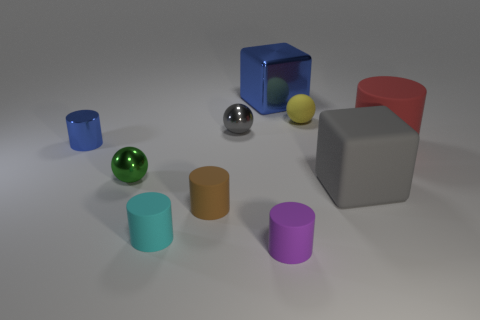What number of large gray matte blocks are in front of the blue thing left of the small purple rubber cylinder?
Offer a terse response. 1. How many matte cylinders are right of the tiny yellow sphere?
Provide a short and direct response. 1. There is a tiny shiny sphere on the left side of the shiny ball behind the blue object that is in front of the big blue object; what is its color?
Your response must be concise. Green. There is a small metal ball in front of the large matte cylinder; is it the same color as the small rubber cylinder behind the tiny cyan cylinder?
Provide a short and direct response. No. There is a small brown rubber object to the left of the big matte thing behind the large rubber cube; what is its shape?
Provide a short and direct response. Cylinder. Are there any green metallic spheres of the same size as the brown matte thing?
Your answer should be compact. Yes. What number of other gray shiny things have the same shape as the tiny gray thing?
Give a very brief answer. 0. Is the number of tiny brown rubber cylinders that are in front of the tiny purple cylinder the same as the number of large objects that are left of the gray matte cube?
Give a very brief answer. No. Is there a large blue shiny object?
Give a very brief answer. Yes. There is a object that is behind the ball that is behind the shiny ball on the right side of the brown rubber object; how big is it?
Your answer should be very brief. Large. 